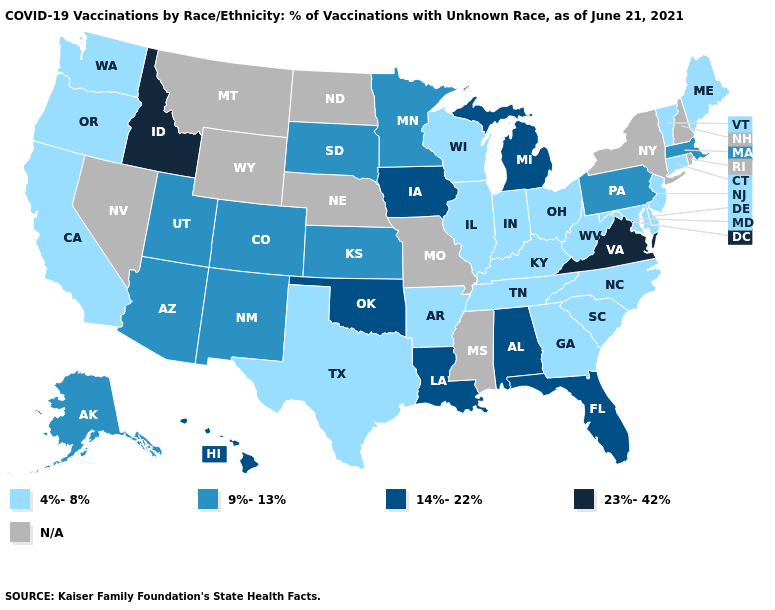Which states have the lowest value in the South?
Be succinct. Arkansas, Delaware, Georgia, Kentucky, Maryland, North Carolina, South Carolina, Tennessee, Texas, West Virginia. Name the states that have a value in the range N/A?
Short answer required. Mississippi, Missouri, Montana, Nebraska, Nevada, New Hampshire, New York, North Dakota, Rhode Island, Wyoming. Is the legend a continuous bar?
Short answer required. No. Does the first symbol in the legend represent the smallest category?
Short answer required. Yes. What is the lowest value in the South?
Answer briefly. 4%-8%. What is the value of Arkansas?
Be succinct. 4%-8%. Is the legend a continuous bar?
Answer briefly. No. Name the states that have a value in the range N/A?
Answer briefly. Mississippi, Missouri, Montana, Nebraska, Nevada, New Hampshire, New York, North Dakota, Rhode Island, Wyoming. What is the value of Wisconsin?
Quick response, please. 4%-8%. Does the map have missing data?
Give a very brief answer. Yes. Among the states that border Idaho , does Oregon have the lowest value?
Short answer required. Yes. What is the value of New Jersey?
Short answer required. 4%-8%. Name the states that have a value in the range 9%-13%?
Short answer required. Alaska, Arizona, Colorado, Kansas, Massachusetts, Minnesota, New Mexico, Pennsylvania, South Dakota, Utah. Name the states that have a value in the range N/A?
Concise answer only. Mississippi, Missouri, Montana, Nebraska, Nevada, New Hampshire, New York, North Dakota, Rhode Island, Wyoming. 